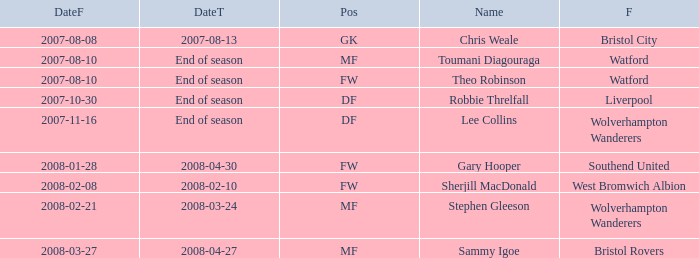What was the from for the Date From of 2007-08-08? Bristol City. 